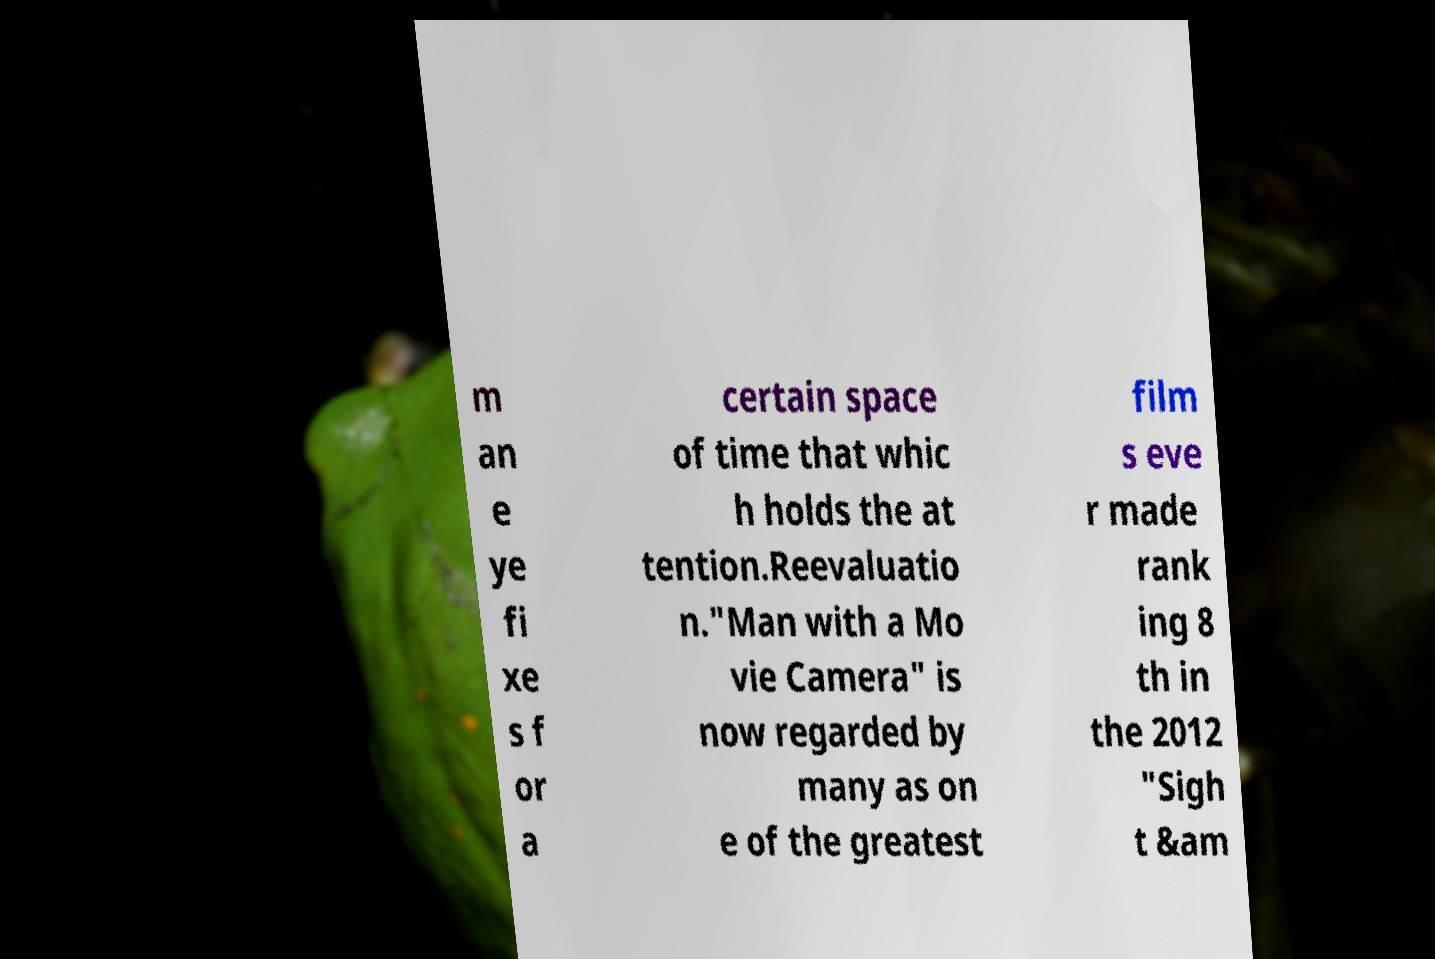For documentation purposes, I need the text within this image transcribed. Could you provide that? m an e ye fi xe s f or a certain space of time that whic h holds the at tention.Reevaluatio n."Man with a Mo vie Camera" is now regarded by many as on e of the greatest film s eve r made rank ing 8 th in the 2012 "Sigh t &am 